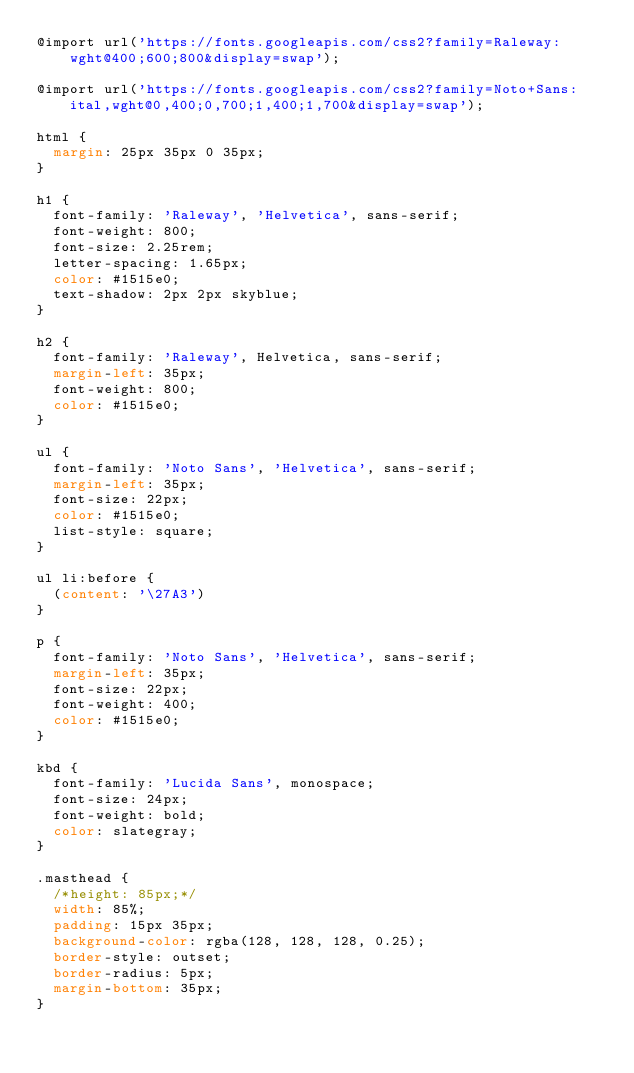<code> <loc_0><loc_0><loc_500><loc_500><_CSS_>@import url('https://fonts.googleapis.com/css2?family=Raleway:wght@400;600;800&display=swap');

@import url('https://fonts.googleapis.com/css2?family=Noto+Sans:ital,wght@0,400;0,700;1,400;1,700&display=swap');

html {
  margin: 25px 35px 0 35px;
}

h1 {
  font-family: 'Raleway', 'Helvetica', sans-serif;
  font-weight: 800;
  font-size: 2.25rem;
  letter-spacing: 1.65px;
  color: #1515e0;
  text-shadow: 2px 2px skyblue;
}

h2 {
  font-family: 'Raleway', Helvetica, sans-serif;
  margin-left: 35px;
  font-weight: 800;
  color: #1515e0;
}

ul {
  font-family: 'Noto Sans', 'Helvetica', sans-serif;
  margin-left: 35px;
  font-size: 22px;
  color: #1515e0;
  list-style: square;
}

ul li:before {
  (content: '\27A3')
}

p {
  font-family: 'Noto Sans', 'Helvetica', sans-serif;
  margin-left: 35px;
  font-size: 22px;
  font-weight: 400;
  color: #1515e0;
}

kbd {
  font-family: 'Lucida Sans', monospace;
  font-size: 24px;
  font-weight: bold;
  color: slategray;
}

.masthead {
  /*height: 85px;*/
  width: 85%;
  padding: 15px 35px;
  background-color: rgba(128, 128, 128, 0.25);
  border-style: outset;
  border-radius: 5px;
  margin-bottom: 35px;
}</code> 